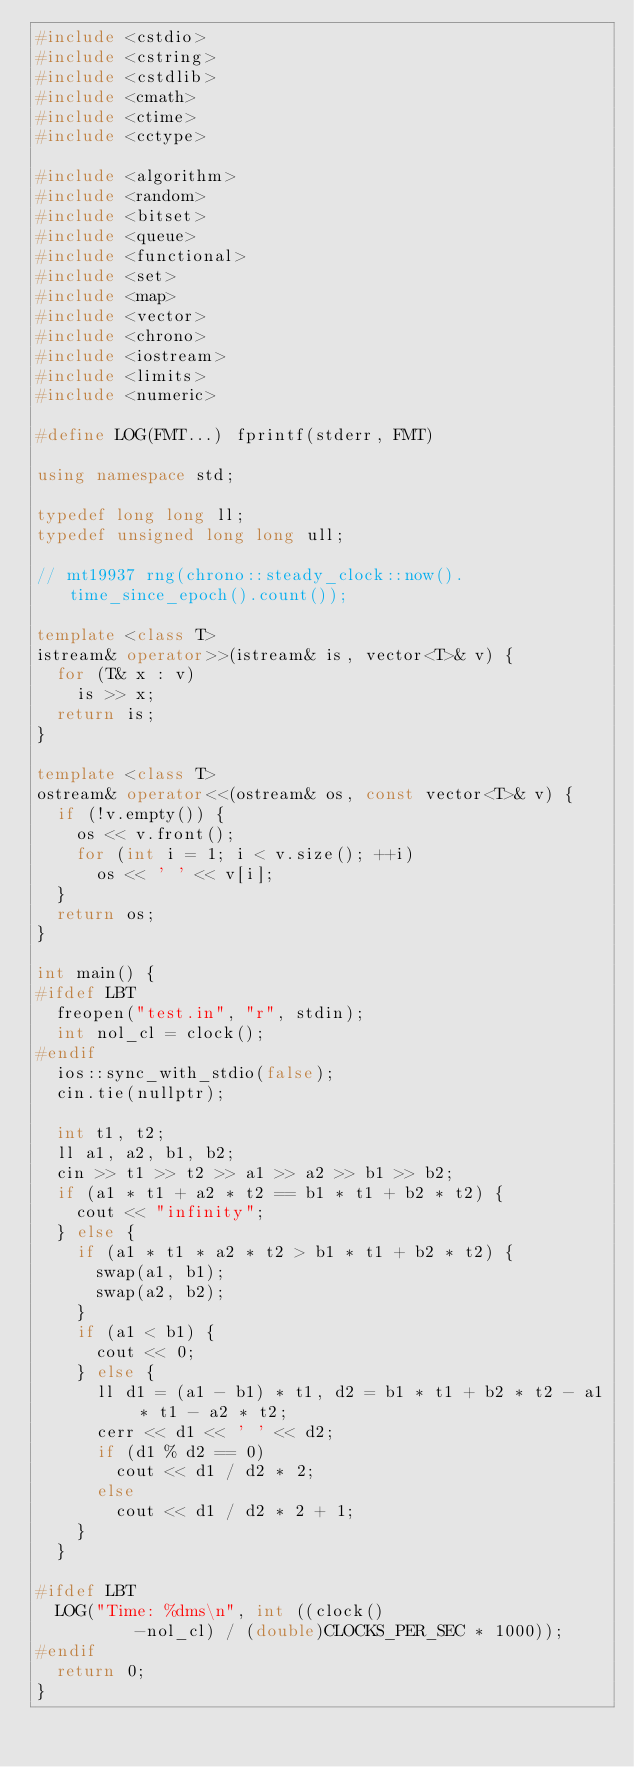Convert code to text. <code><loc_0><loc_0><loc_500><loc_500><_C++_>#include <cstdio>
#include <cstring>
#include <cstdlib>
#include <cmath>
#include <ctime>
#include <cctype>

#include <algorithm>
#include <random>
#include <bitset>
#include <queue>
#include <functional>
#include <set>
#include <map>
#include <vector>
#include <chrono>
#include <iostream>
#include <limits>
#include <numeric>

#define LOG(FMT...) fprintf(stderr, FMT)

using namespace std;

typedef long long ll;
typedef unsigned long long ull;

// mt19937 rng(chrono::steady_clock::now().time_since_epoch().count());

template <class T>
istream& operator>>(istream& is, vector<T>& v) {
  for (T& x : v)
    is >> x;
  return is;
}

template <class T>
ostream& operator<<(ostream& os, const vector<T>& v) {
  if (!v.empty()) {
    os << v.front();
    for (int i = 1; i < v.size(); ++i)
      os << ' ' << v[i];
  }
  return os;
}

int main() {
#ifdef LBT
  freopen("test.in", "r", stdin);
  int nol_cl = clock();
#endif
  ios::sync_with_stdio(false);
  cin.tie(nullptr);

  int t1, t2;
  ll a1, a2, b1, b2;
  cin >> t1 >> t2 >> a1 >> a2 >> b1 >> b2;
  if (a1 * t1 + a2 * t2 == b1 * t1 + b2 * t2) {
    cout << "infinity";
  } else {
    if (a1 * t1 * a2 * t2 > b1 * t1 + b2 * t2) {
      swap(a1, b1);
      swap(a2, b2);
    }
    if (a1 < b1) {
      cout << 0;
    } else {
      ll d1 = (a1 - b1) * t1, d2 = b1 * t1 + b2 * t2 - a1 * t1 - a2 * t2;
      cerr << d1 << ' ' << d2;
      if (d1 % d2 == 0)
        cout << d1 / d2 * 2;
      else
        cout << d1 / d2 * 2 + 1;
    }
  }

#ifdef LBT
  LOG("Time: %dms\n", int ((clock()
          -nol_cl) / (double)CLOCKS_PER_SEC * 1000));
#endif
  return 0;
}
</code> 